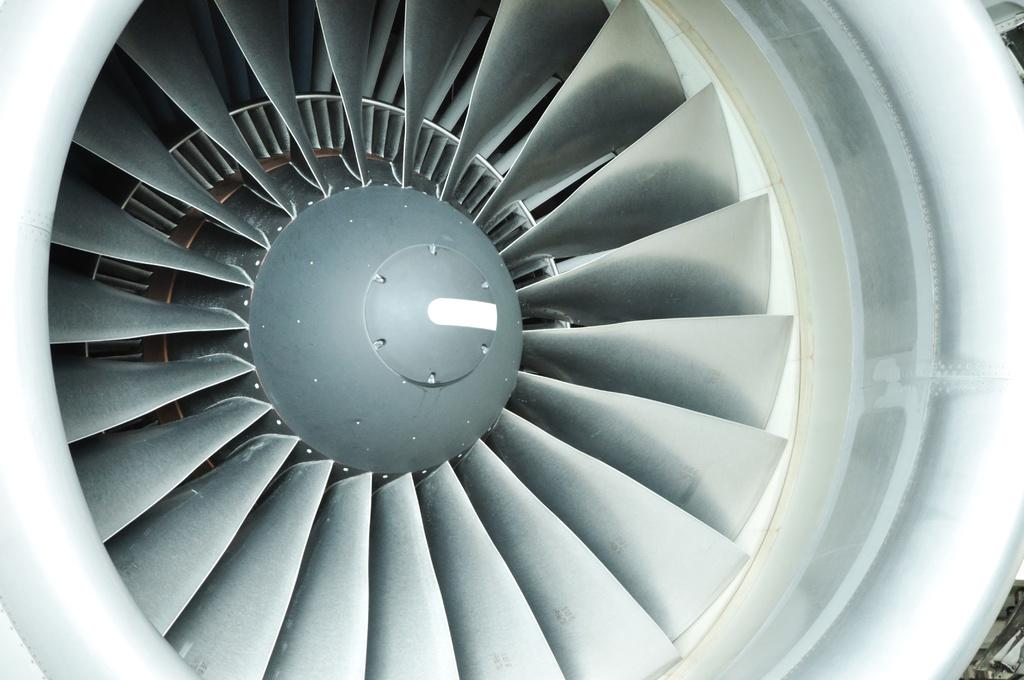What is the main subject of the image? The main subject of the image is a turbine jet engine. Where is the sofa located in the image? There is no sofa present in the image; it only features a turbine jet engine. What type of bottle is visible in the image? There is no bottle present in the image; it only features a turbine jet engine. 